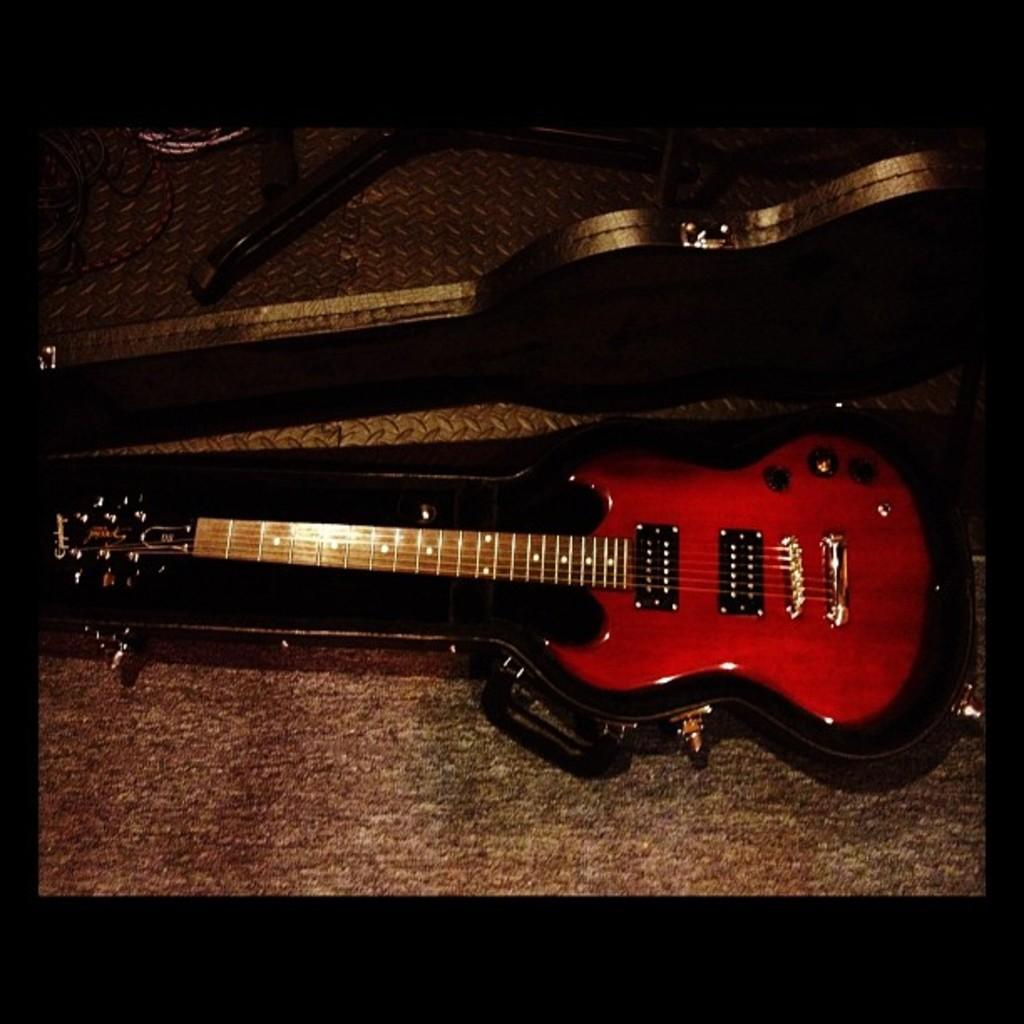What type of musical instrument is in the image? There is a red guitar in the image. How is the guitar being stored or transported? The guitar is inside a guitar case. What is used to hold the guitar upright when not in the case? There is a guitar stand in the image. What type of flooring is visible in the image? There is a carpet on the ground in the image. What is the guitar's wealth status in the image? The image does not provide information about the guitar's wealth status; it only shows the guitar, guitar case, guitar stand, and carpet. 